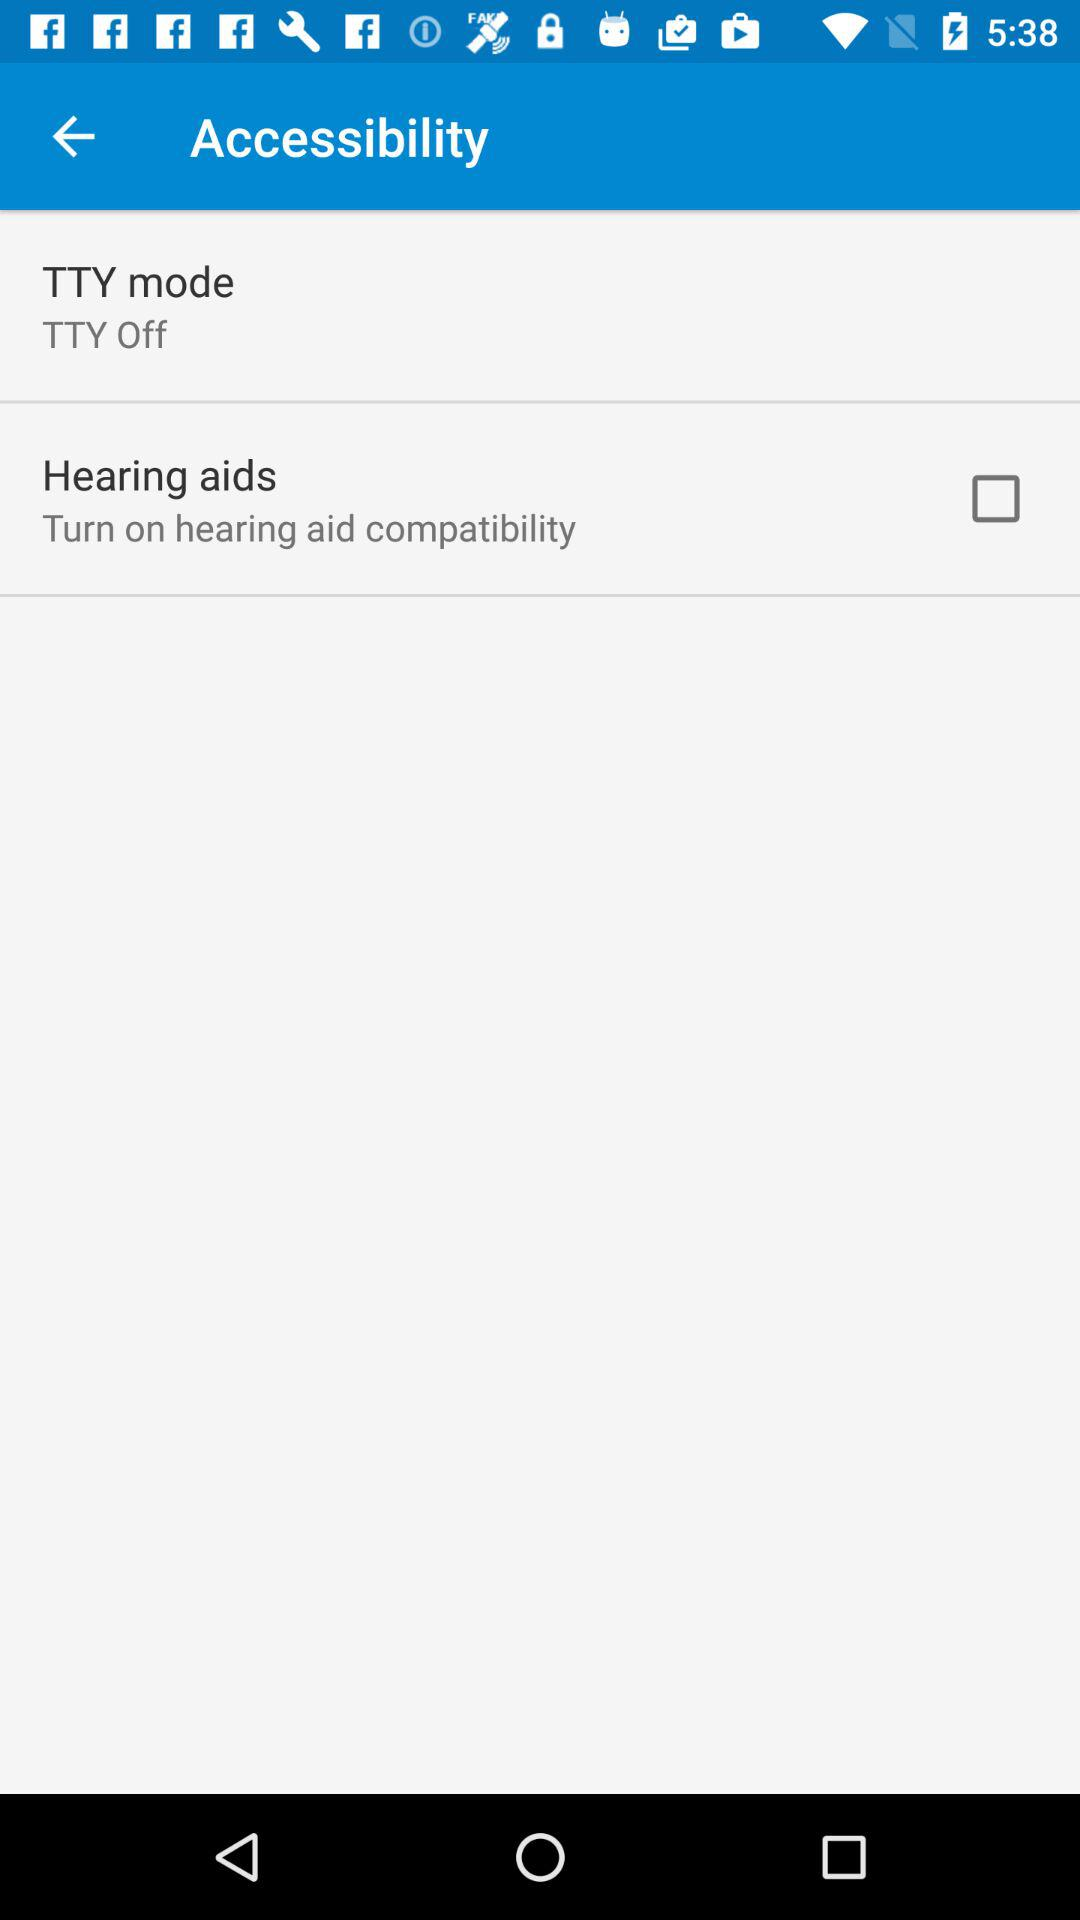What is the status of "Hearing aids"? The status is "off". 